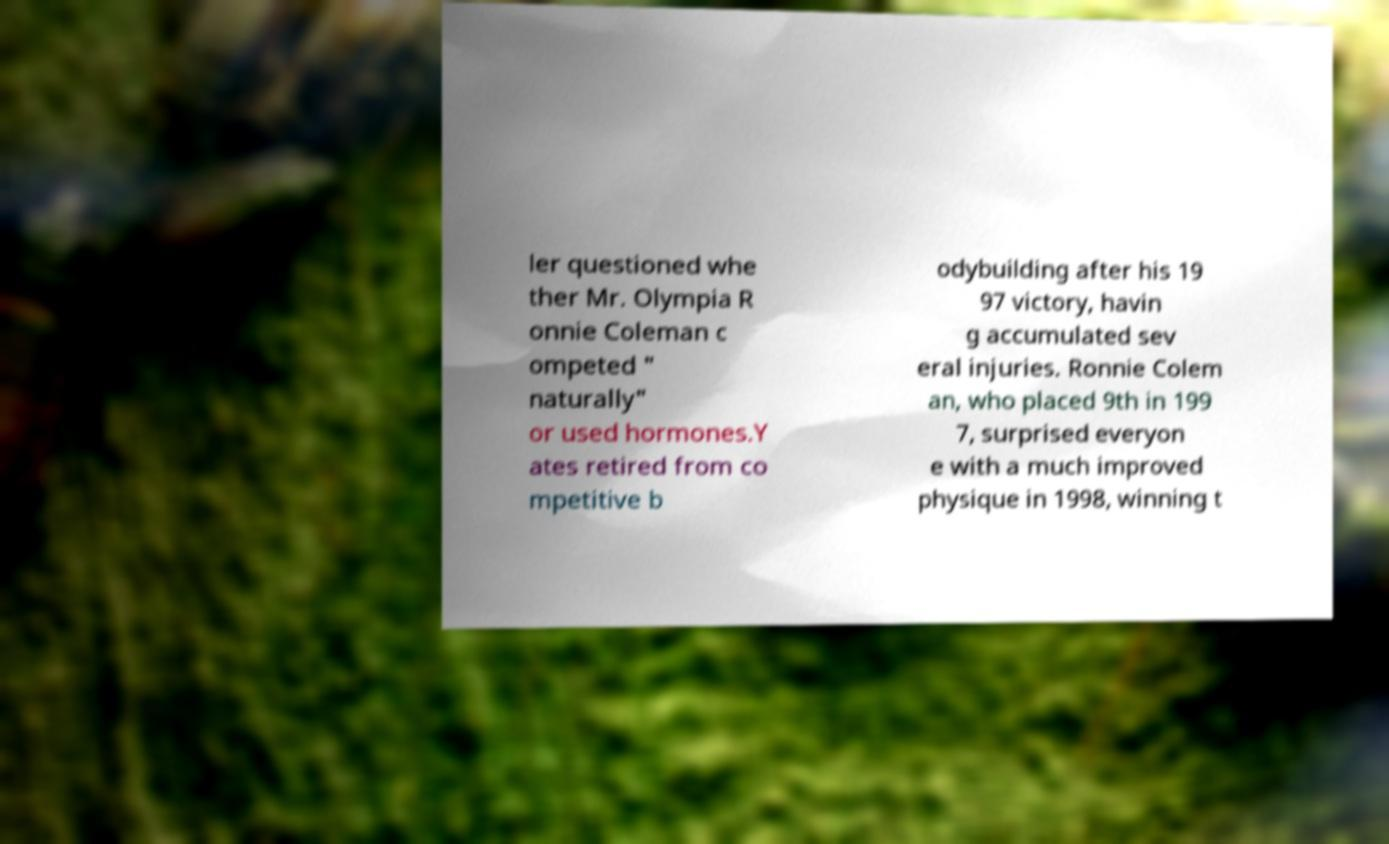What messages or text are displayed in this image? I need them in a readable, typed format. ler questioned whe ther Mr. Olympia R onnie Coleman c ompeted " naturally" or used hormones.Y ates retired from co mpetitive b odybuilding after his 19 97 victory, havin g accumulated sev eral injuries. Ronnie Colem an, who placed 9th in 199 7, surprised everyon e with a much improved physique in 1998, winning t 